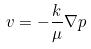<formula> <loc_0><loc_0><loc_500><loc_500>v = - \frac { k } { \mu } \nabla p</formula> 